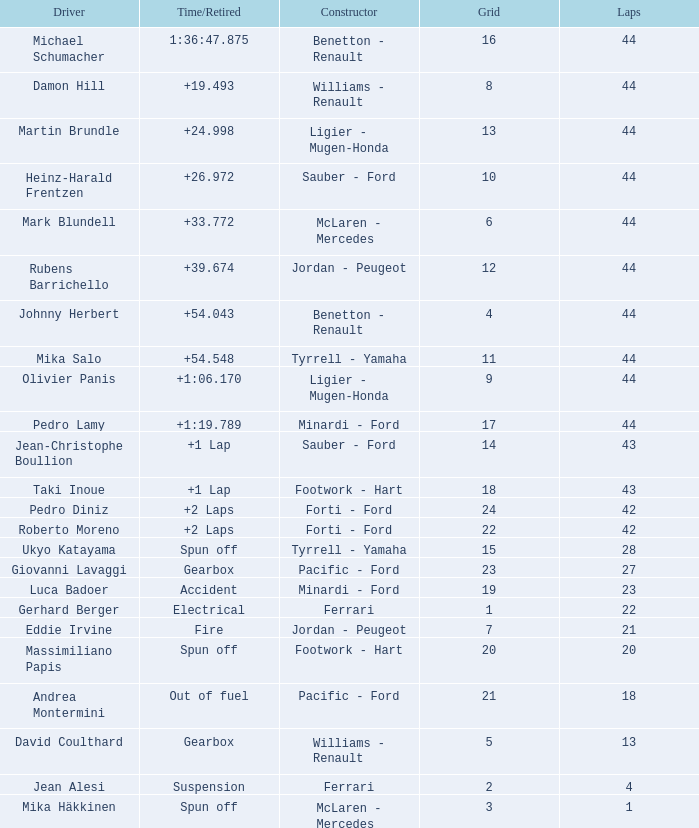Who built the car that ran out of fuel before 28 laps? Pacific - Ford. 